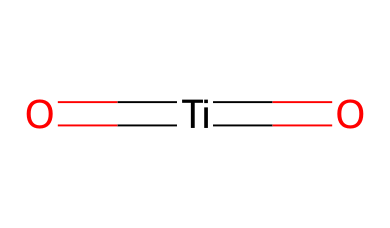What is the central atom in this chemical structure? The structure shows titanium (Ti) as the central atom, around which the rest of the chemical is organized.
Answer: titanium How many oxygen atoms are present in this compound? In the SMILES notation, there are two oxygen atoms (indicated by the "=O" and "O" connected to the titanium), which leads to a total of two O atoms.
Answer: two What type of bonding is present between titanium and oxygen? The presence of the double bond (indicated by "=") between titanium and one of the oxygen atoms suggests that there are both single and double bonds in this compound.
Answer: both Is titanium dioxide a conductive material? Generally, titanium dioxide (TiO2) is known to have semiconducting properties rather than good electrical conductivity, making it less conductive.
Answer: no What is a common use of this nanoparticles? Titanium dioxide nanoparticles are widely used for their UV filtering capabilities, making them essential in sunscreen formulations.
Answer: sunscreen 